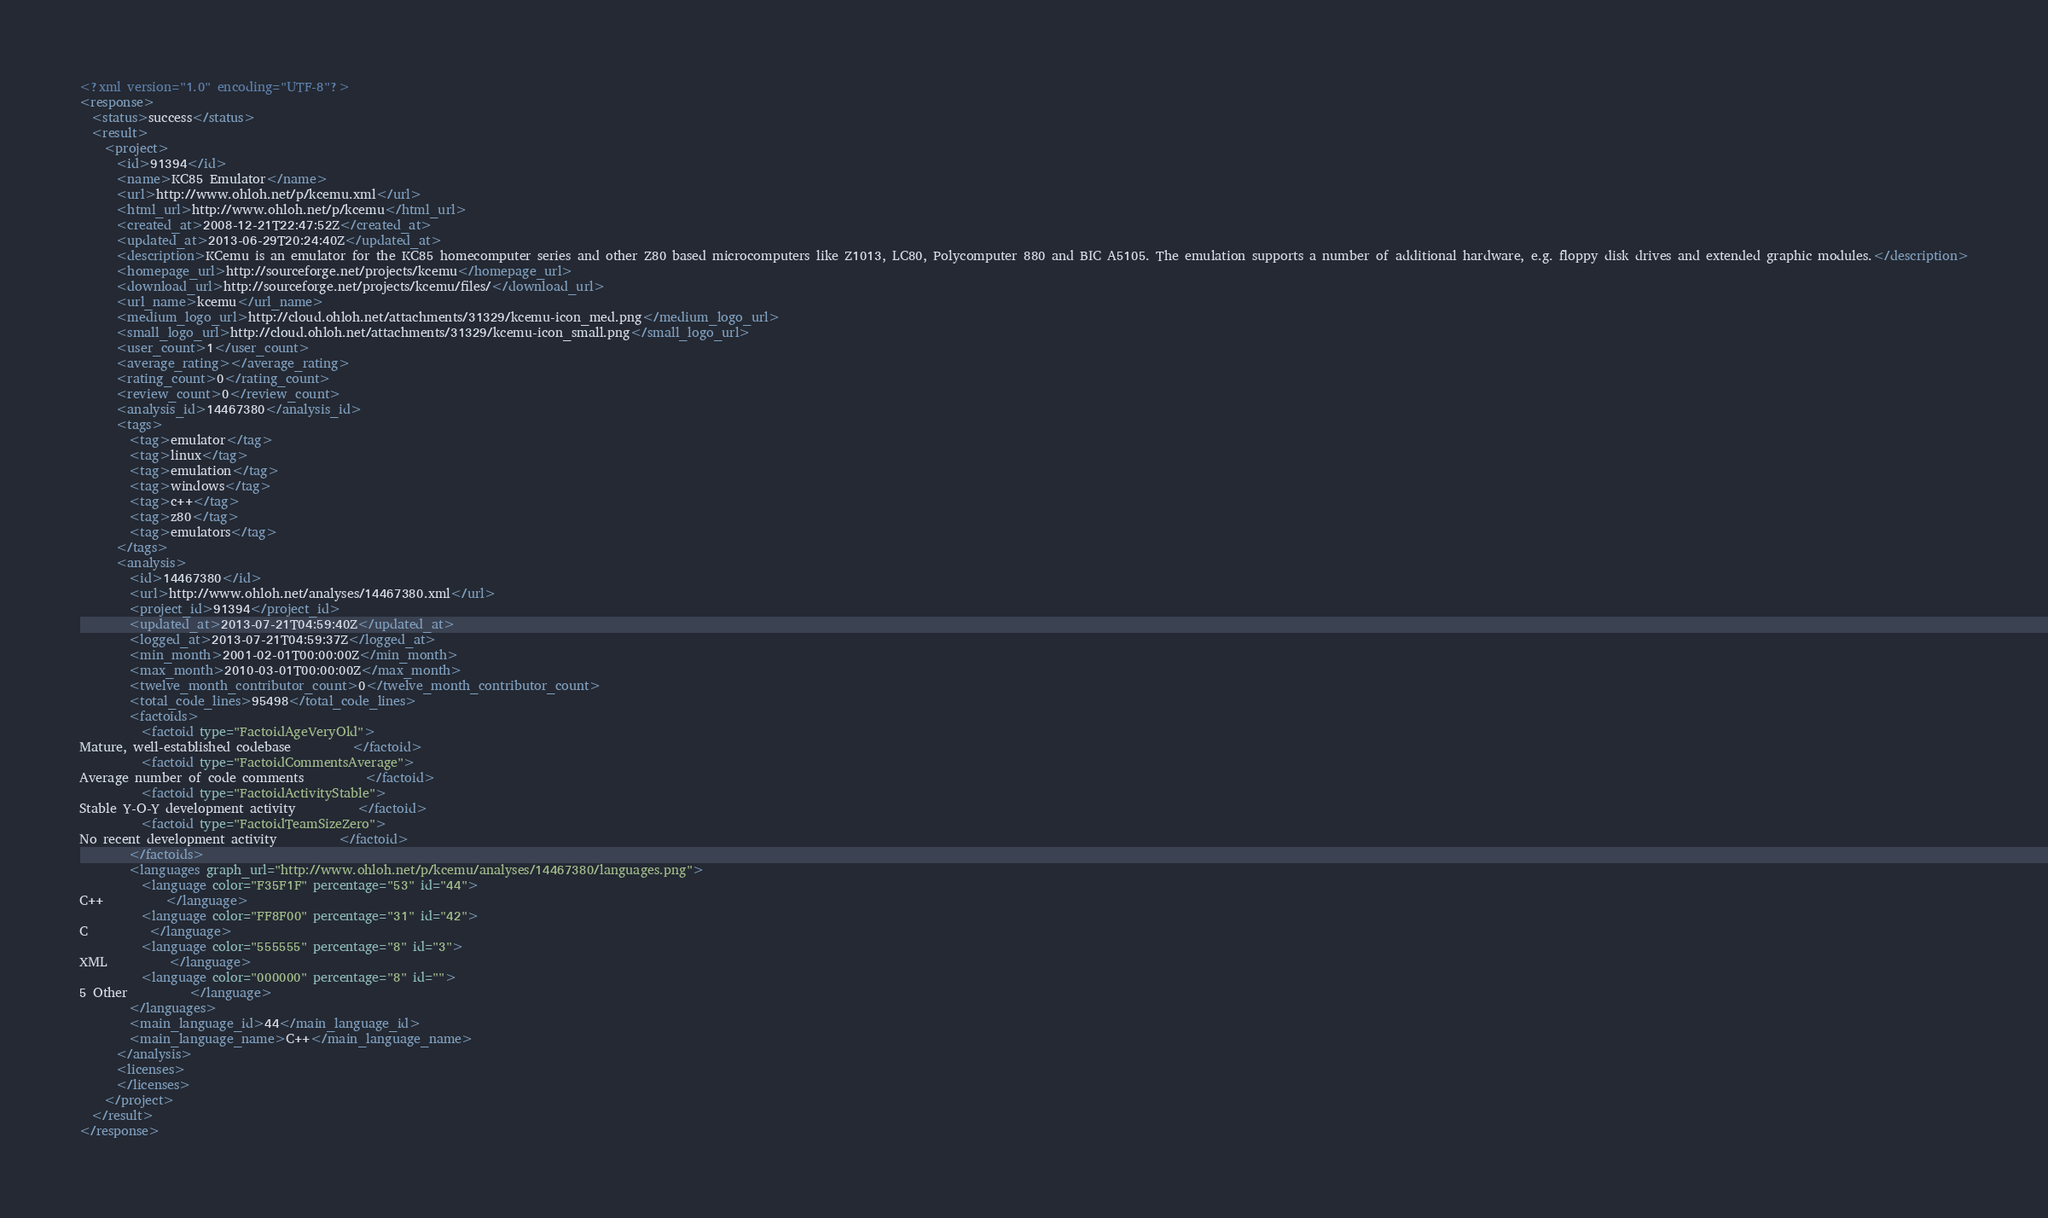<code> <loc_0><loc_0><loc_500><loc_500><_XML_><?xml version="1.0" encoding="UTF-8"?>
<response>
  <status>success</status>
  <result>
    <project>
      <id>91394</id>
      <name>KC85 Emulator</name>
      <url>http://www.ohloh.net/p/kcemu.xml</url>
      <html_url>http://www.ohloh.net/p/kcemu</html_url>
      <created_at>2008-12-21T22:47:52Z</created_at>
      <updated_at>2013-06-29T20:24:40Z</updated_at>
      <description>KCemu is an emulator for the KC85 homecomputer series and other Z80 based microcomputers like Z1013, LC80, Polycomputer 880 and BIC A5105. The emulation supports a number of additional hardware, e.g. floppy disk drives and extended graphic modules.</description>
      <homepage_url>http://sourceforge.net/projects/kcemu</homepage_url>
      <download_url>http://sourceforge.net/projects/kcemu/files/</download_url>
      <url_name>kcemu</url_name>
      <medium_logo_url>http://cloud.ohloh.net/attachments/31329/kcemu-icon_med.png</medium_logo_url>
      <small_logo_url>http://cloud.ohloh.net/attachments/31329/kcemu-icon_small.png</small_logo_url>
      <user_count>1</user_count>
      <average_rating></average_rating>
      <rating_count>0</rating_count>
      <review_count>0</review_count>
      <analysis_id>14467380</analysis_id>
      <tags>
        <tag>emulator</tag>
        <tag>linux</tag>
        <tag>emulation</tag>
        <tag>windows</tag>
        <tag>c++</tag>
        <tag>z80</tag>
        <tag>emulators</tag>
      </tags>
      <analysis>
        <id>14467380</id>
        <url>http://www.ohloh.net/analyses/14467380.xml</url>
        <project_id>91394</project_id>
        <updated_at>2013-07-21T04:59:40Z</updated_at>
        <logged_at>2013-07-21T04:59:37Z</logged_at>
        <min_month>2001-02-01T00:00:00Z</min_month>
        <max_month>2010-03-01T00:00:00Z</max_month>
        <twelve_month_contributor_count>0</twelve_month_contributor_count>
        <total_code_lines>95498</total_code_lines>
        <factoids>
          <factoid type="FactoidAgeVeryOld">
Mature, well-established codebase          </factoid>
          <factoid type="FactoidCommentsAverage">
Average number of code comments          </factoid>
          <factoid type="FactoidActivityStable">
Stable Y-O-Y development activity          </factoid>
          <factoid type="FactoidTeamSizeZero">
No recent development activity          </factoid>
        </factoids>
        <languages graph_url="http://www.ohloh.net/p/kcemu/analyses/14467380/languages.png">
          <language color="F35F1F" percentage="53" id="44">
C++          </language>
          <language color="FF8F00" percentage="31" id="42">
C          </language>
          <language color="555555" percentage="8" id="3">
XML          </language>
          <language color="000000" percentage="8" id="">
5 Other          </language>
        </languages>
        <main_language_id>44</main_language_id>
        <main_language_name>C++</main_language_name>
      </analysis>
      <licenses>
      </licenses>
    </project>
  </result>
</response>
</code> 